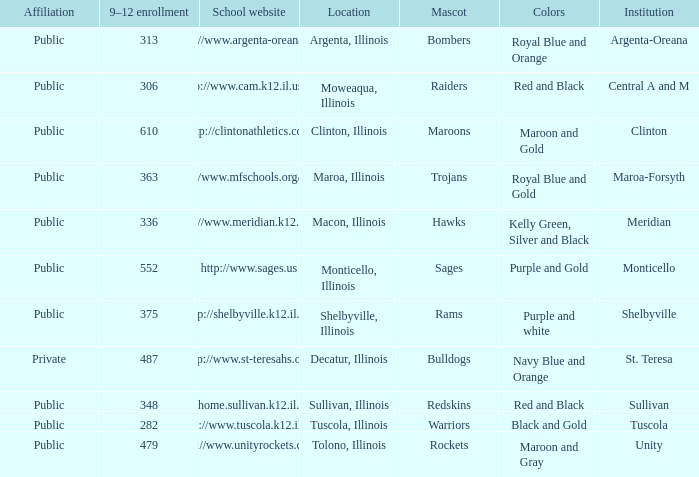What's the name of the city or town of the school that operates the http://www.mfschools.org/high/ website? Maroa-Forsyth. Give me the full table as a dictionary. {'header': ['Affiliation', '9–12 enrollment', 'School website', 'Location', 'Mascot', 'Colors', 'Institution'], 'rows': [['Public', '313', 'http://www.argenta-oreana.org', 'Argenta, Illinois', 'Bombers', 'Royal Blue and Orange', 'Argenta-Oreana'], ['Public', '306', 'http://www.cam.k12.il.us/hs', 'Moweaqua, Illinois', 'Raiders', 'Red and Black', 'Central A and M'], ['Public', '610', 'http://clintonathletics.com', 'Clinton, Illinois', 'Maroons', 'Maroon and Gold', 'Clinton'], ['Public', '363', 'http://www.mfschools.org/high/', 'Maroa, Illinois', 'Trojans', 'Royal Blue and Gold', 'Maroa-Forsyth'], ['Public', '336', 'http://www.meridian.k12.il.us/', 'Macon, Illinois', 'Hawks', 'Kelly Green, Silver and Black', 'Meridian'], ['Public', '552', 'http://www.sages.us', 'Monticello, Illinois', 'Sages', 'Purple and Gold', 'Monticello'], ['Public', '375', 'http://shelbyville.k12.il.us/', 'Shelbyville, Illinois', 'Rams', 'Purple and white', 'Shelbyville'], ['Private', '487', 'http://www.st-teresahs.org/', 'Decatur, Illinois', 'Bulldogs', 'Navy Blue and Orange', 'St. Teresa'], ['Public', '348', 'http://home.sullivan.k12.il.us/shs', 'Sullivan, Illinois', 'Redskins', 'Red and Black', 'Sullivan'], ['Public', '282', 'http://www.tuscola.k12.il.us/', 'Tuscola, Illinois', 'Warriors', 'Black and Gold', 'Tuscola'], ['Public', '479', 'http://www.unityrockets.com/', 'Tolono, Illinois', 'Rockets', 'Maroon and Gray', 'Unity']]} 